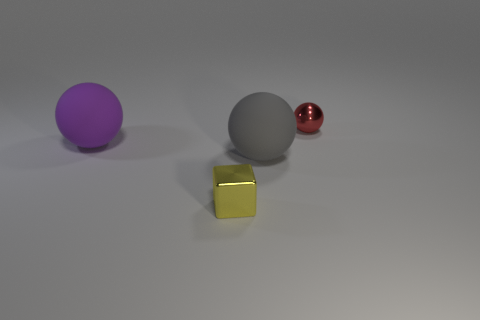Add 3 purple shiny things. How many objects exist? 7 Subtract all spheres. How many objects are left? 1 Add 1 shiny cylinders. How many shiny cylinders exist? 1 Subtract 0 green cylinders. How many objects are left? 4 Subtract all spheres. Subtract all blocks. How many objects are left? 0 Add 2 large gray matte things. How many large gray matte things are left? 3 